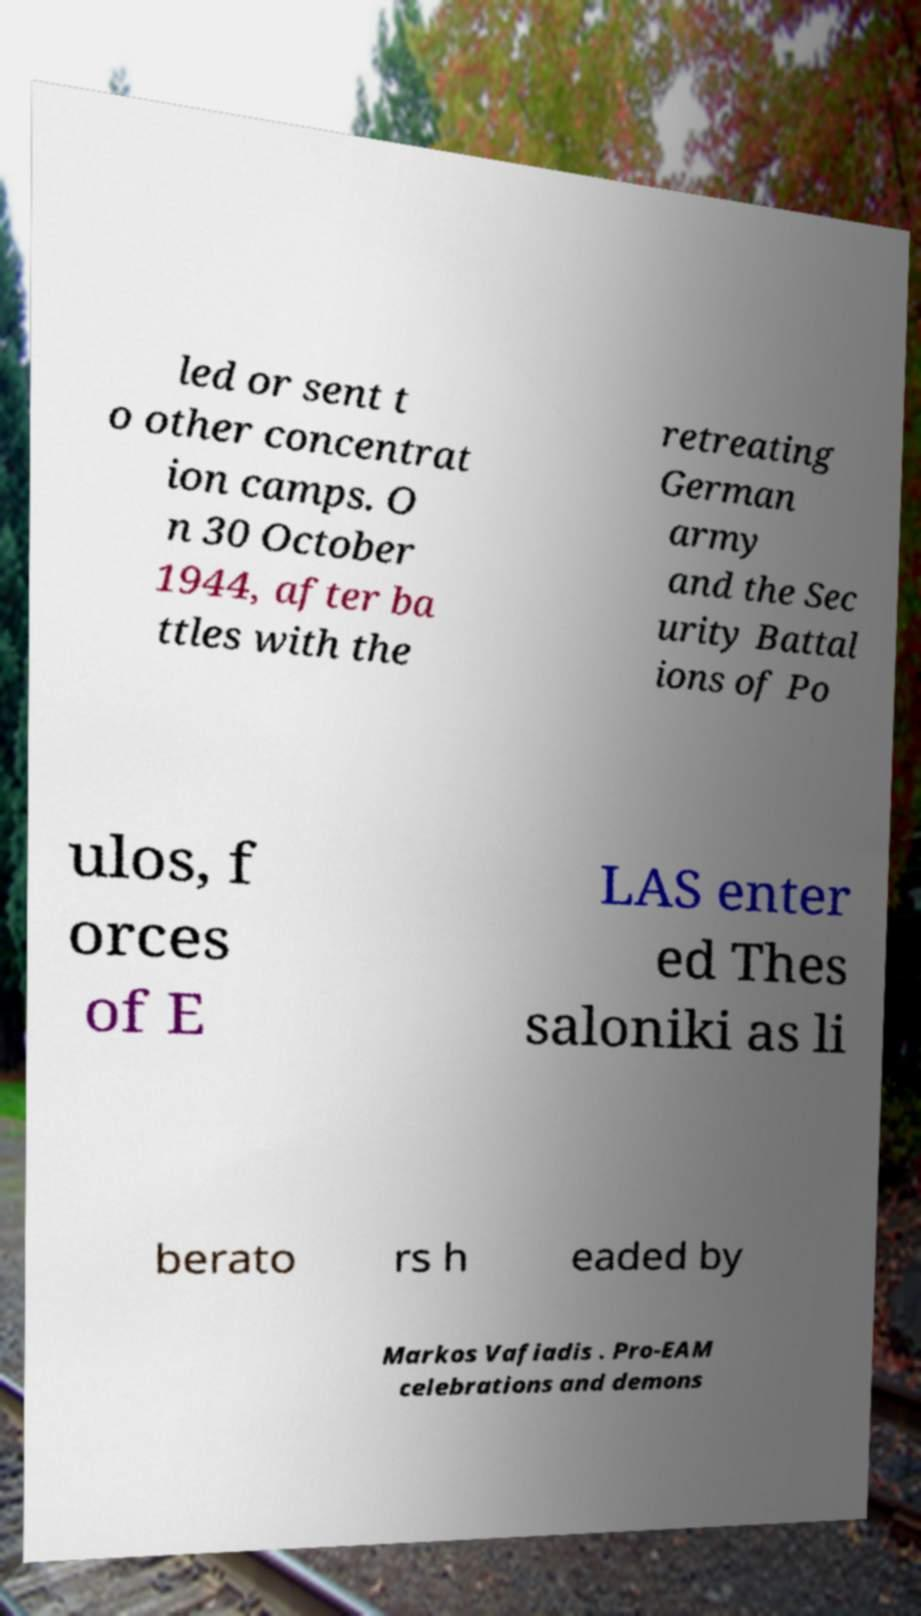I need the written content from this picture converted into text. Can you do that? led or sent t o other concentrat ion camps. O n 30 October 1944, after ba ttles with the retreating German army and the Sec urity Battal ions of Po ulos, f orces of E LAS enter ed Thes saloniki as li berato rs h eaded by Markos Vafiadis . Pro-EAM celebrations and demons 